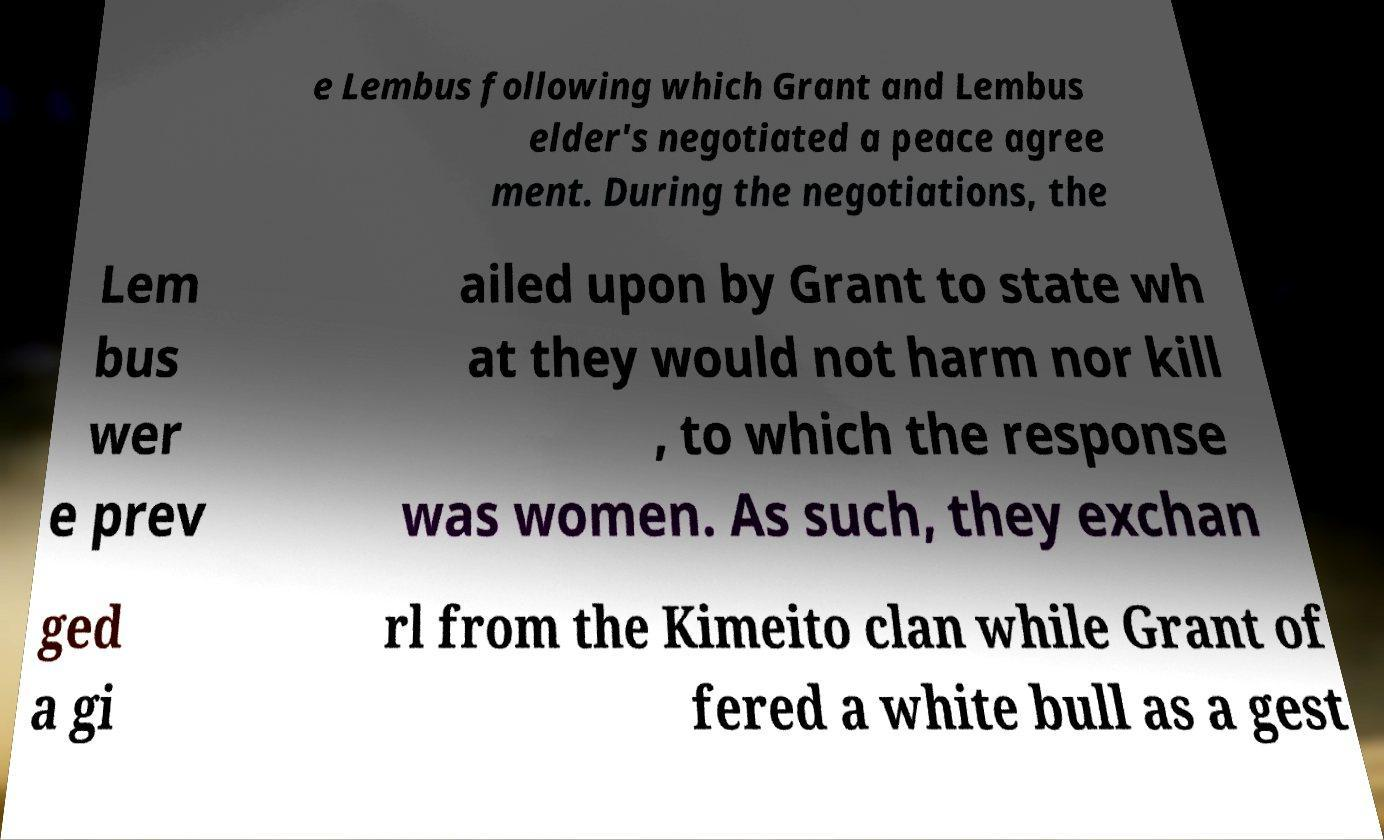Could you extract and type out the text from this image? e Lembus following which Grant and Lembus elder's negotiated a peace agree ment. During the negotiations, the Lem bus wer e prev ailed upon by Grant to state wh at they would not harm nor kill , to which the response was women. As such, they exchan ged a gi rl from the Kimeito clan while Grant of fered a white bull as a gest 